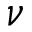<formula> <loc_0><loc_0><loc_500><loc_500>\nu</formula> 